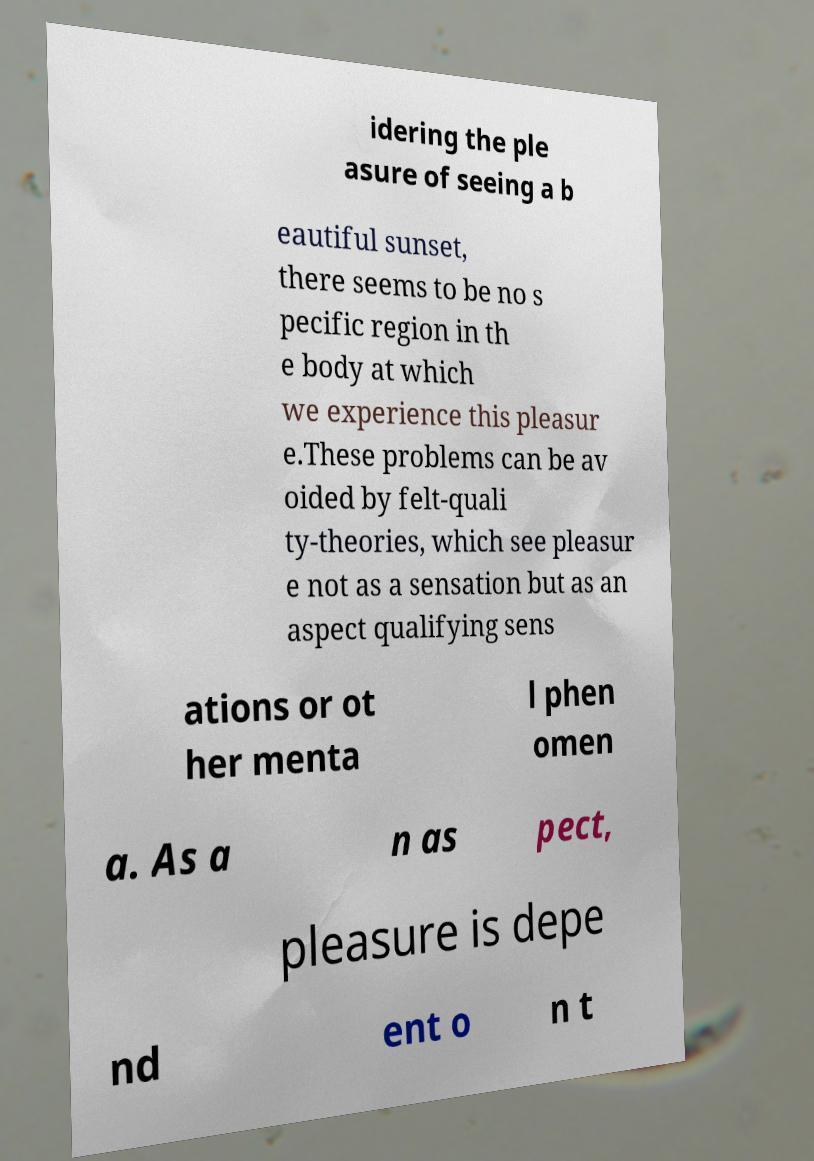Can you accurately transcribe the text from the provided image for me? idering the ple asure of seeing a b eautiful sunset, there seems to be no s pecific region in th e body at which we experience this pleasur e.These problems can be av oided by felt-quali ty-theories, which see pleasur e not as a sensation but as an aspect qualifying sens ations or ot her menta l phen omen a. As a n as pect, pleasure is depe nd ent o n t 